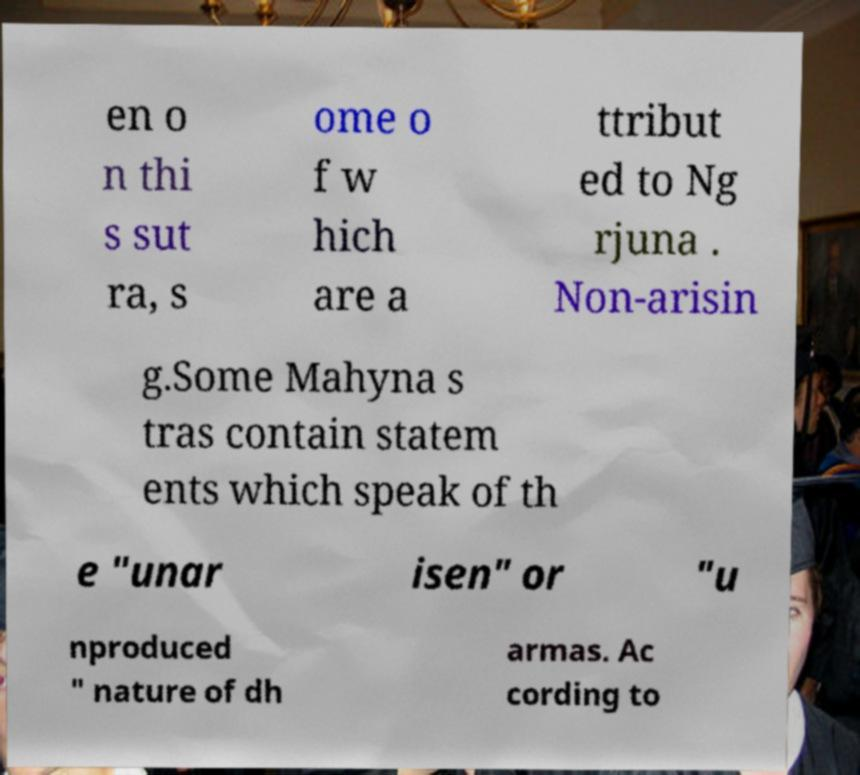For documentation purposes, I need the text within this image transcribed. Could you provide that? en o n thi s sut ra, s ome o f w hich are a ttribut ed to Ng rjuna . Non-arisin g.Some Mahyna s tras contain statem ents which speak of th e "unar isen" or "u nproduced " nature of dh armas. Ac cording to 